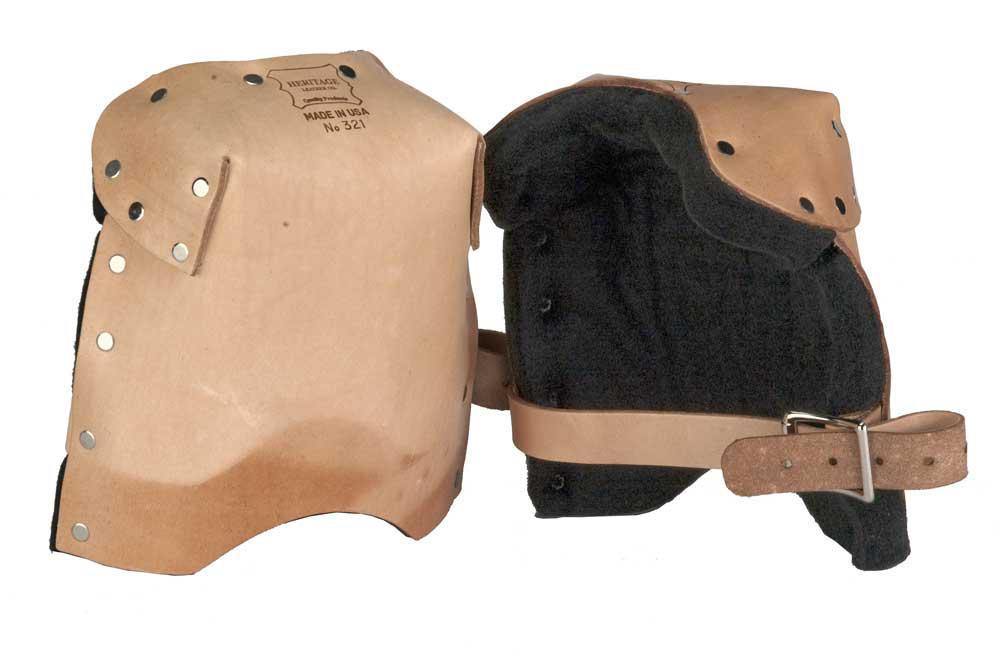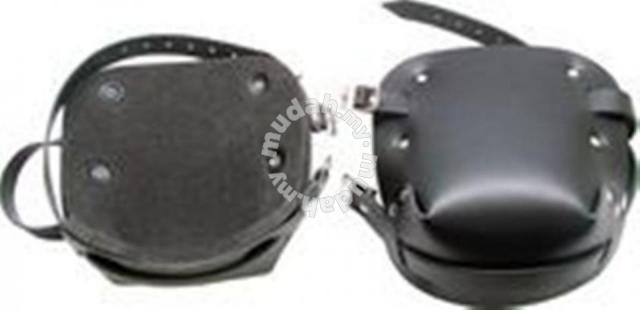The first image is the image on the left, the second image is the image on the right. Analyze the images presented: Is the assertion "The kneepads on the left are brown and black, and the pair on the right are solid black." valid? Answer yes or no. Yes. The first image is the image on the left, the second image is the image on the right. Evaluate the accuracy of this statement regarding the images: "There are two charcoal colored knee pads with similar colored straps in the image on the right.". Is it true? Answer yes or no. Yes. 